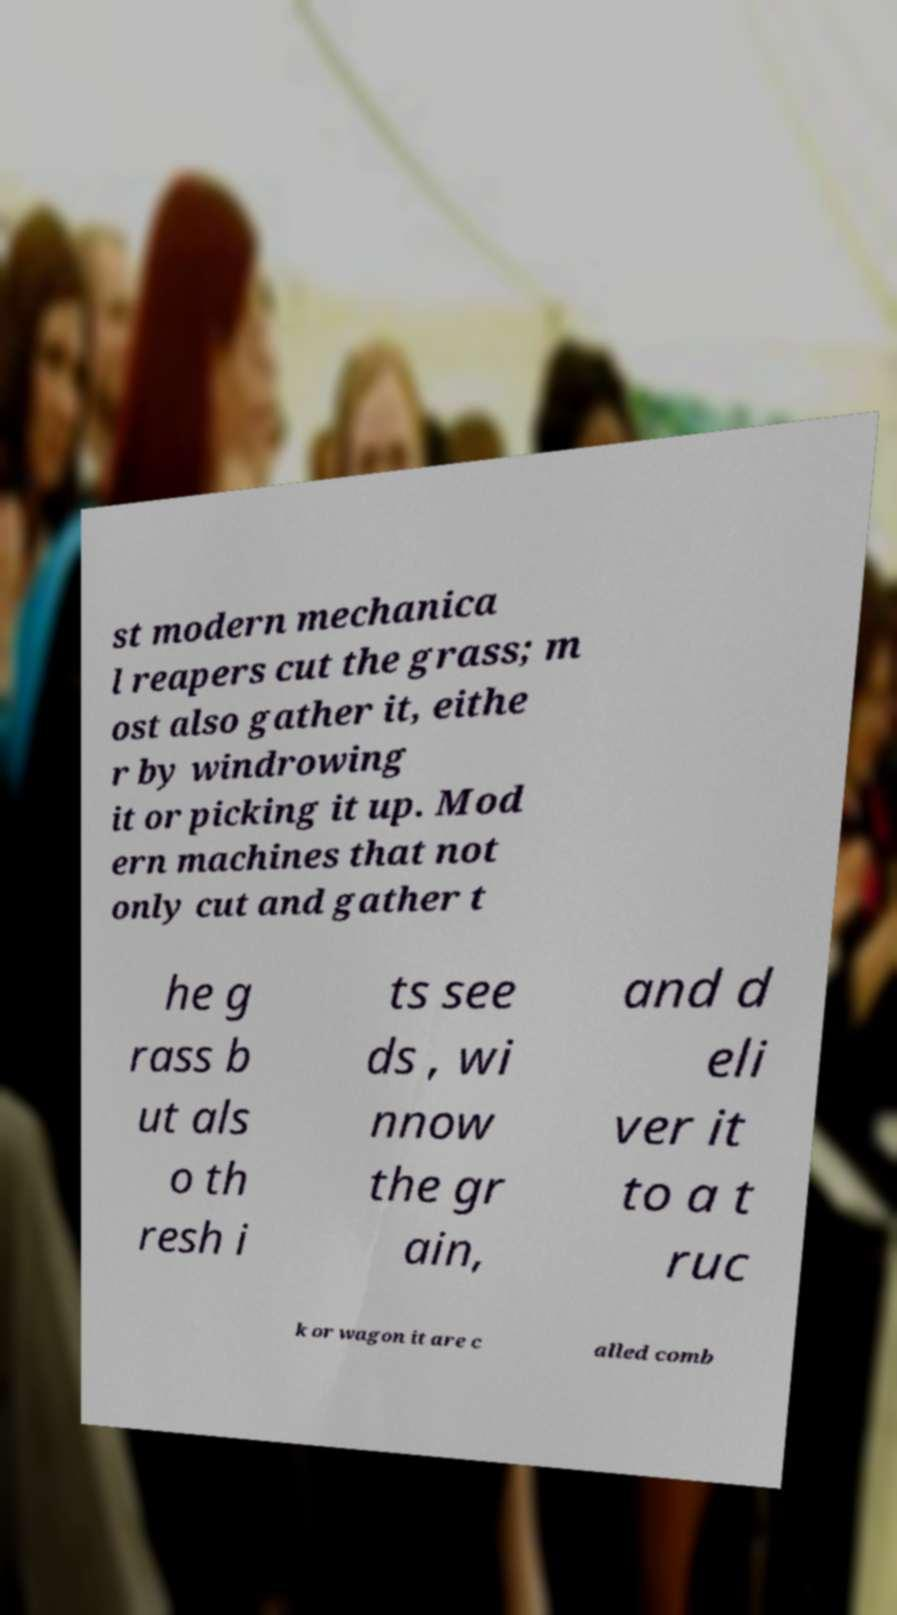I need the written content from this picture converted into text. Can you do that? st modern mechanica l reapers cut the grass; m ost also gather it, eithe r by windrowing it or picking it up. Mod ern machines that not only cut and gather t he g rass b ut als o th resh i ts see ds , wi nnow the gr ain, and d eli ver it to a t ruc k or wagon it are c alled comb 